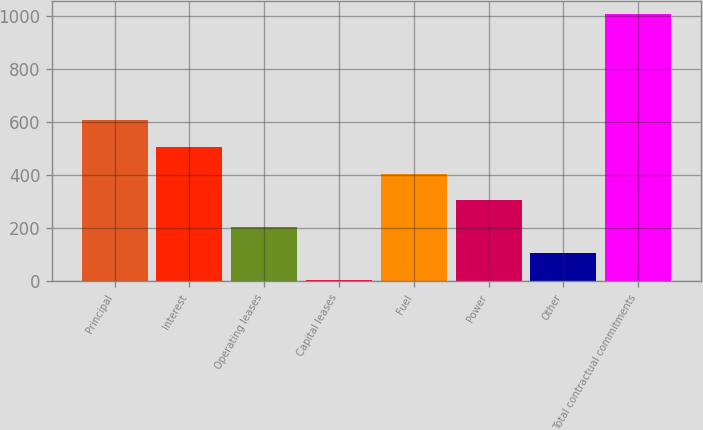Convert chart to OTSL. <chart><loc_0><loc_0><loc_500><loc_500><bar_chart><fcel>Principal<fcel>Interest<fcel>Operating leases<fcel>Capital leases<fcel>Fuel<fcel>Power<fcel>Other<fcel>Total contractual commitments<nl><fcel>605.72<fcel>505.65<fcel>205.44<fcel>5.3<fcel>405.58<fcel>305.51<fcel>105.37<fcel>1006<nl></chart> 